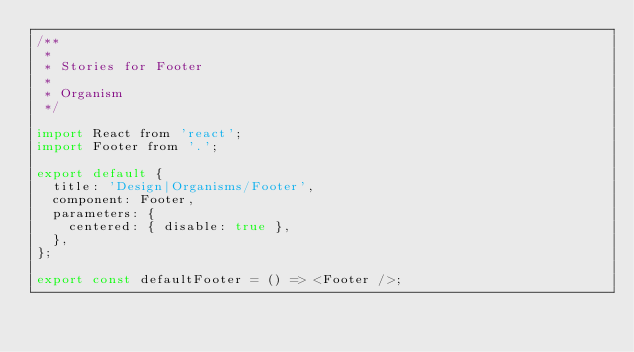<code> <loc_0><loc_0><loc_500><loc_500><_JavaScript_>/**
 *
 * Stories for Footer
 *
 * Organism
 */

import React from 'react';
import Footer from '.';

export default {
  title: 'Design|Organisms/Footer',
  component: Footer,
  parameters: {
    centered: { disable: true },
  },
};

export const defaultFooter = () => <Footer />;
</code> 